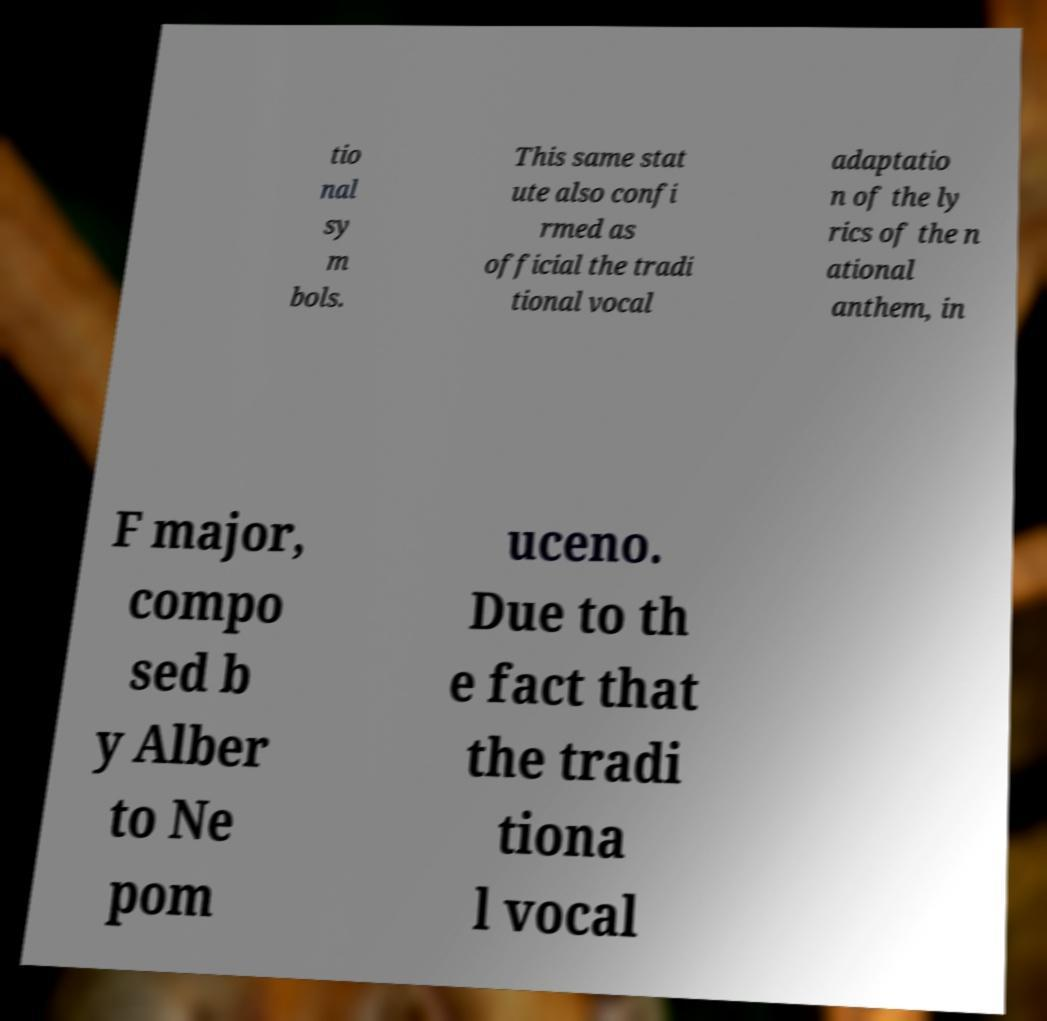Can you accurately transcribe the text from the provided image for me? tio nal sy m bols. This same stat ute also confi rmed as official the tradi tional vocal adaptatio n of the ly rics of the n ational anthem, in F major, compo sed b y Alber to Ne pom uceno. Due to th e fact that the tradi tiona l vocal 